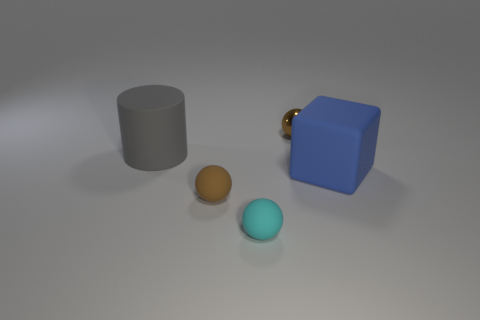Subtract all small brown shiny balls. How many balls are left? 2 Subtract 1 balls. How many balls are left? 2 Add 3 spheres. How many objects exist? 8 Subtract all spheres. How many objects are left? 2 Add 1 small matte objects. How many small matte objects are left? 3 Add 1 tiny yellow objects. How many tiny yellow objects exist? 1 Subtract 0 cyan cylinders. How many objects are left? 5 Subtract all small gray metal blocks. Subtract all brown things. How many objects are left? 3 